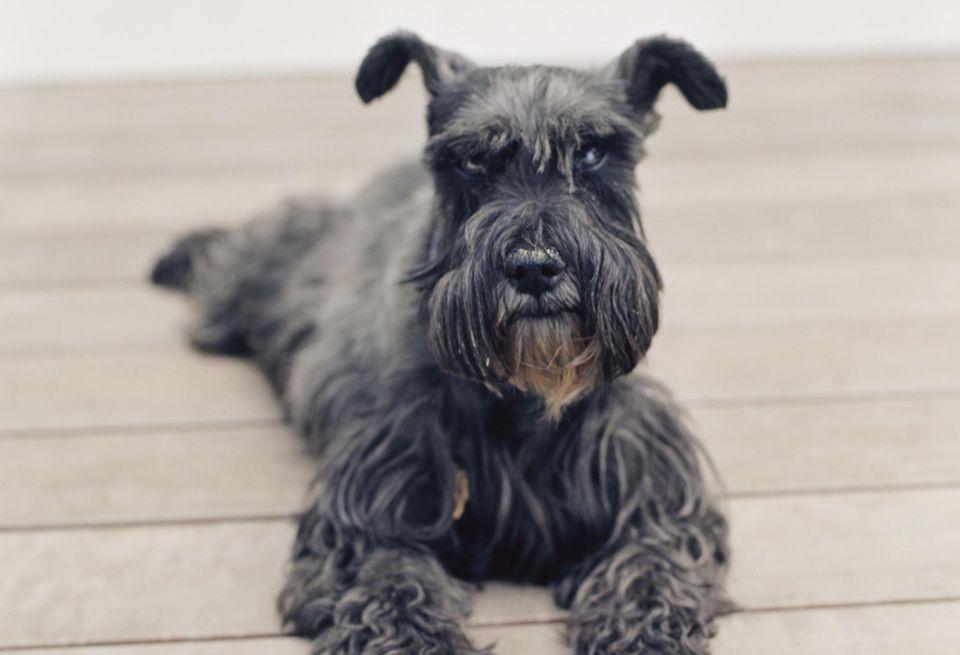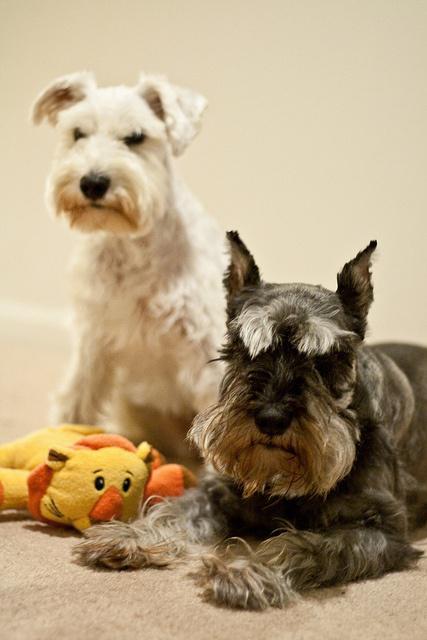The first image is the image on the left, the second image is the image on the right. Analyze the images presented: Is the assertion "An image shows a schnauzer posed on a wood plank floor." valid? Answer yes or no. Yes. The first image is the image on the left, the second image is the image on the right. Considering the images on both sides, is "A dog is sitting on wood floor." valid? Answer yes or no. Yes. 